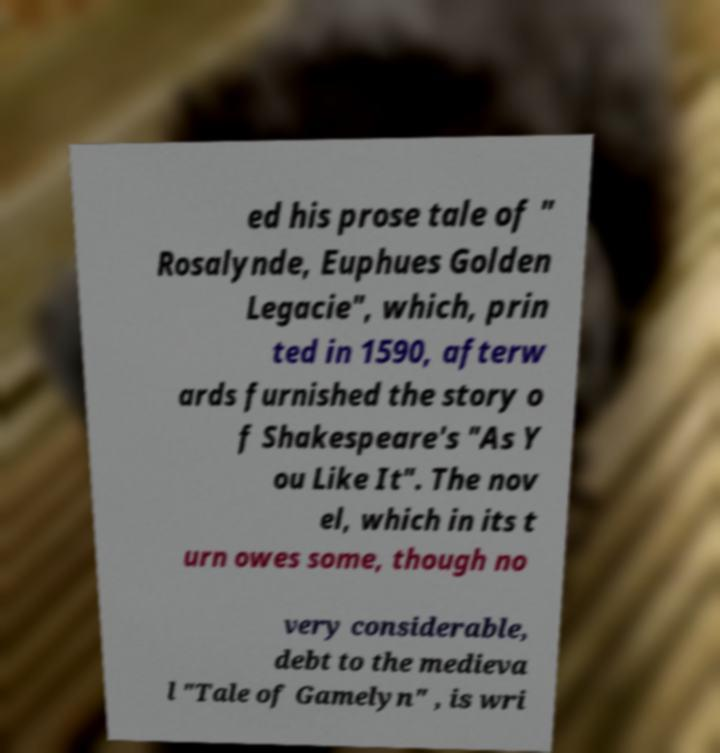There's text embedded in this image that I need extracted. Can you transcribe it verbatim? ed his prose tale of " Rosalynde, Euphues Golden Legacie", which, prin ted in 1590, afterw ards furnished the story o f Shakespeare's "As Y ou Like It". The nov el, which in its t urn owes some, though no very considerable, debt to the medieva l "Tale of Gamelyn" , is wri 